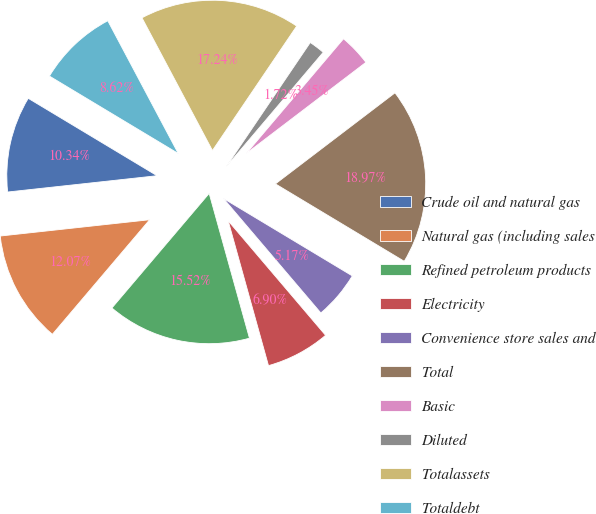Convert chart. <chart><loc_0><loc_0><loc_500><loc_500><pie_chart><fcel>Crude oil and natural gas<fcel>Natural gas (including sales<fcel>Refined petroleum products<fcel>Electricity<fcel>Convenience store sales and<fcel>Total<fcel>Basic<fcel>Diluted<fcel>Totalassets<fcel>Totaldebt<nl><fcel>10.34%<fcel>12.07%<fcel>15.52%<fcel>6.9%<fcel>5.17%<fcel>18.97%<fcel>3.45%<fcel>1.72%<fcel>17.24%<fcel>8.62%<nl></chart> 